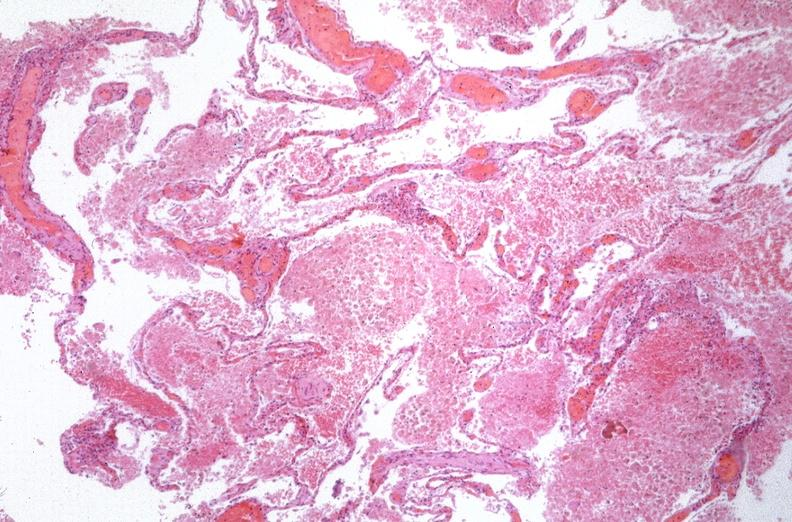does this image show lung, emphysema and pneumonia, alpha-1 antitrypsin deficiency?
Answer the question using a single word or phrase. Yes 